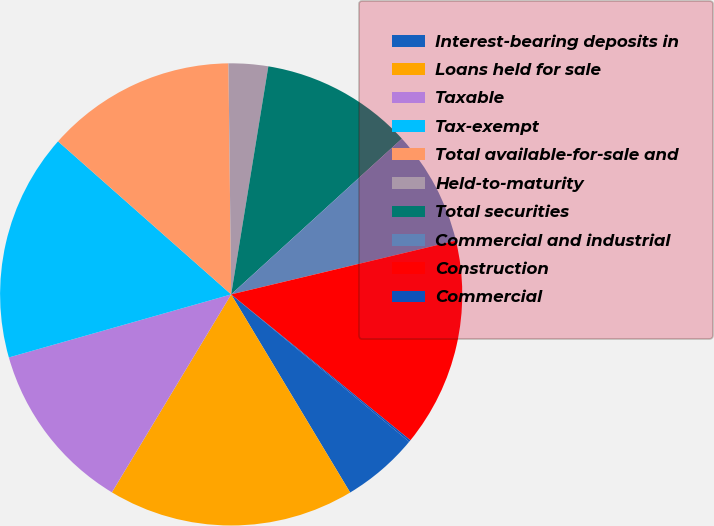Convert chart. <chart><loc_0><loc_0><loc_500><loc_500><pie_chart><fcel>Interest-bearing deposits in<fcel>Loans held for sale<fcel>Taxable<fcel>Tax-exempt<fcel>Total available-for-sale and<fcel>Held-to-maturity<fcel>Total securities<fcel>Commercial and industrial<fcel>Construction<fcel>Commercial<nl><fcel>5.39%<fcel>17.24%<fcel>11.97%<fcel>15.92%<fcel>13.29%<fcel>2.76%<fcel>10.66%<fcel>8.03%<fcel>14.61%<fcel>0.13%<nl></chart> 